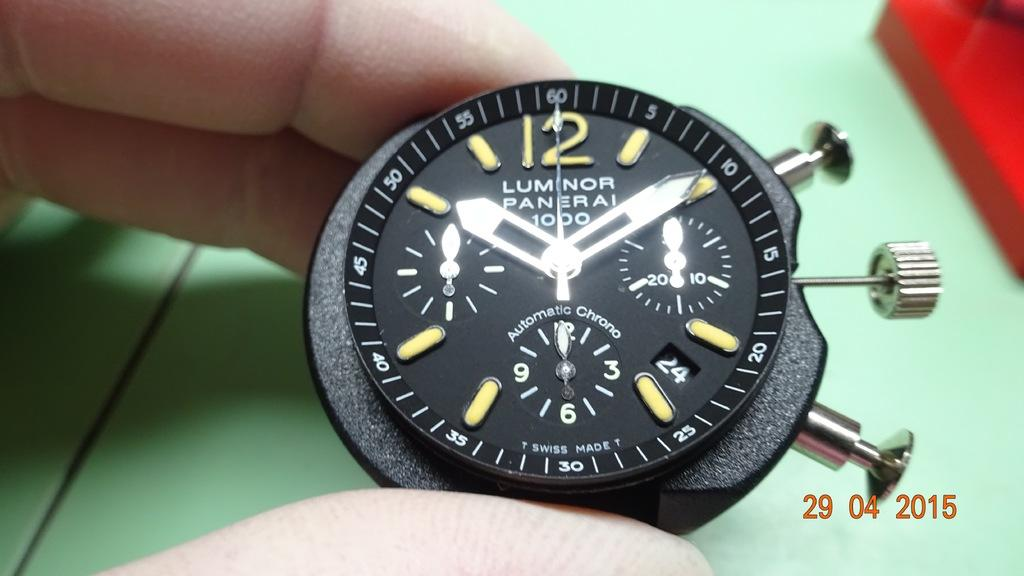Provide a one-sentence caption for the provided image. Person holding a black and yellow wristwatch which says Luminor Panerai on it. 